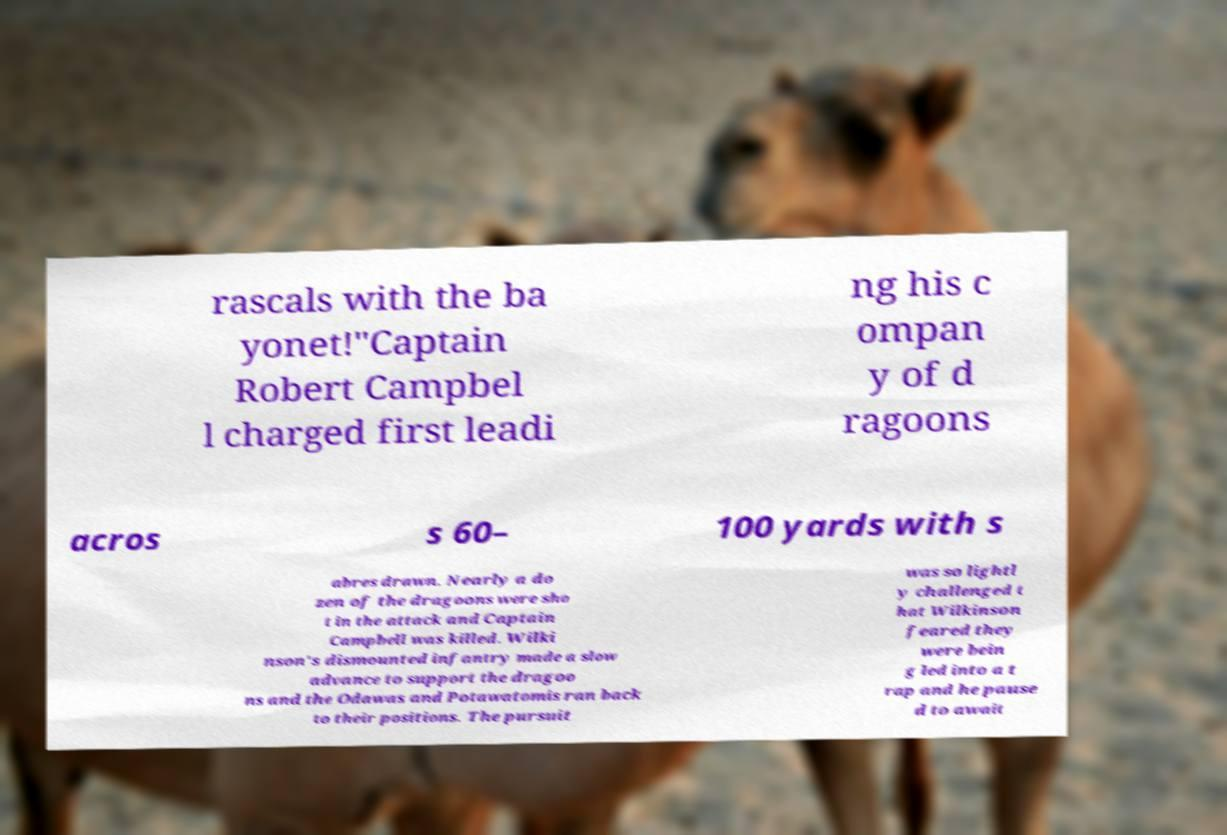There's text embedded in this image that I need extracted. Can you transcribe it verbatim? rascals with the ba yonet!"Captain Robert Campbel l charged first leadi ng his c ompan y of d ragoons acros s 60– 100 yards with s abres drawn. Nearly a do zen of the dragoons were sho t in the attack and Captain Campbell was killed. Wilki nson's dismounted infantry made a slow advance to support the dragoo ns and the Odawas and Potawatomis ran back to their positions. The pursuit was so lightl y challenged t hat Wilkinson feared they were bein g led into a t rap and he pause d to await 